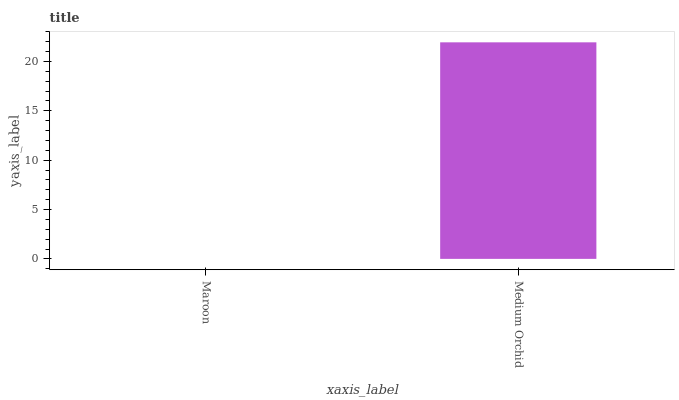Is Maroon the minimum?
Answer yes or no. Yes. Is Medium Orchid the maximum?
Answer yes or no. Yes. Is Medium Orchid the minimum?
Answer yes or no. No. Is Medium Orchid greater than Maroon?
Answer yes or no. Yes. Is Maroon less than Medium Orchid?
Answer yes or no. Yes. Is Maroon greater than Medium Orchid?
Answer yes or no. No. Is Medium Orchid less than Maroon?
Answer yes or no. No. Is Medium Orchid the high median?
Answer yes or no. Yes. Is Maroon the low median?
Answer yes or no. Yes. Is Maroon the high median?
Answer yes or no. No. Is Medium Orchid the low median?
Answer yes or no. No. 